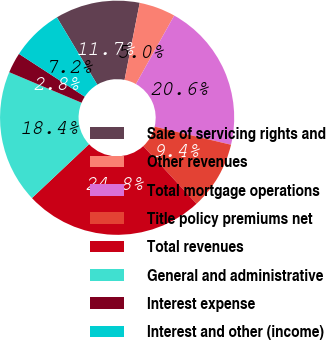Convert chart. <chart><loc_0><loc_0><loc_500><loc_500><pie_chart><fcel>Sale of servicing rights and<fcel>Other revenues<fcel>Total mortgage operations<fcel>Title policy premiums net<fcel>Total revenues<fcel>General and administrative<fcel>Interest expense<fcel>Interest and other (income)<nl><fcel>11.69%<fcel>5.02%<fcel>20.59%<fcel>9.43%<fcel>24.83%<fcel>18.39%<fcel>2.82%<fcel>7.22%<nl></chart> 